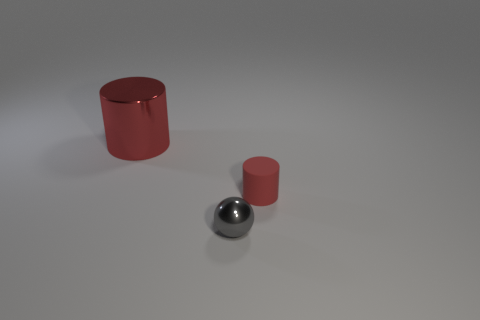Add 2 small gray objects. How many objects exist? 5 Subtract all cylinders. How many objects are left? 1 Add 1 large red things. How many large red things are left? 2 Add 2 big shiny things. How many big shiny things exist? 3 Subtract 0 green spheres. How many objects are left? 3 Subtract all gray shiny balls. Subtract all cylinders. How many objects are left? 0 